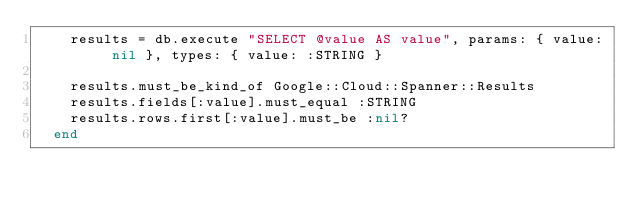<code> <loc_0><loc_0><loc_500><loc_500><_Ruby_>    results = db.execute "SELECT @value AS value", params: { value: nil }, types: { value: :STRING }

    results.must_be_kind_of Google::Cloud::Spanner::Results
    results.fields[:value].must_equal :STRING
    results.rows.first[:value].must_be :nil?
  end
</code> 